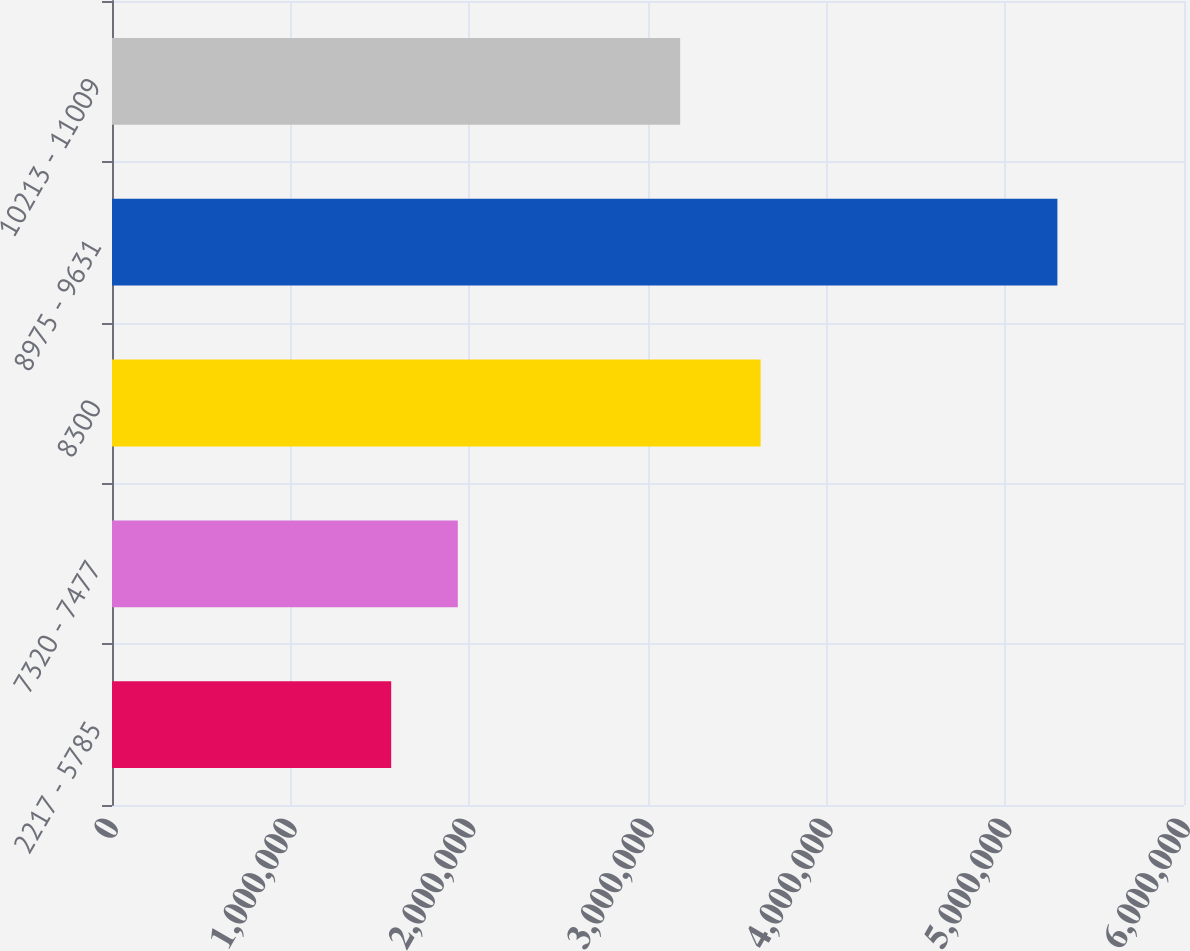Convert chart. <chart><loc_0><loc_0><loc_500><loc_500><bar_chart><fcel>2217 - 5785<fcel>7320 - 7477<fcel>8300<fcel>8975 - 9631<fcel>10213 - 11009<nl><fcel>1.56267e+06<fcel>1.93554e+06<fcel>3.63034e+06<fcel>5.29141e+06<fcel>3.18012e+06<nl></chart> 